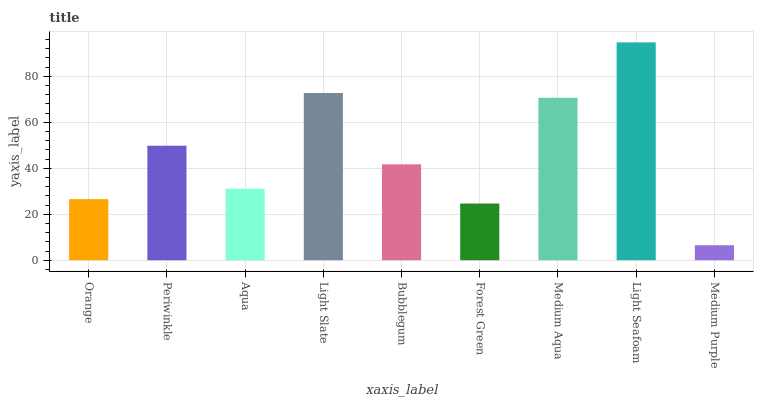Is Periwinkle the minimum?
Answer yes or no. No. Is Periwinkle the maximum?
Answer yes or no. No. Is Periwinkle greater than Orange?
Answer yes or no. Yes. Is Orange less than Periwinkle?
Answer yes or no. Yes. Is Orange greater than Periwinkle?
Answer yes or no. No. Is Periwinkle less than Orange?
Answer yes or no. No. Is Bubblegum the high median?
Answer yes or no. Yes. Is Bubblegum the low median?
Answer yes or no. Yes. Is Medium Aqua the high median?
Answer yes or no. No. Is Aqua the low median?
Answer yes or no. No. 